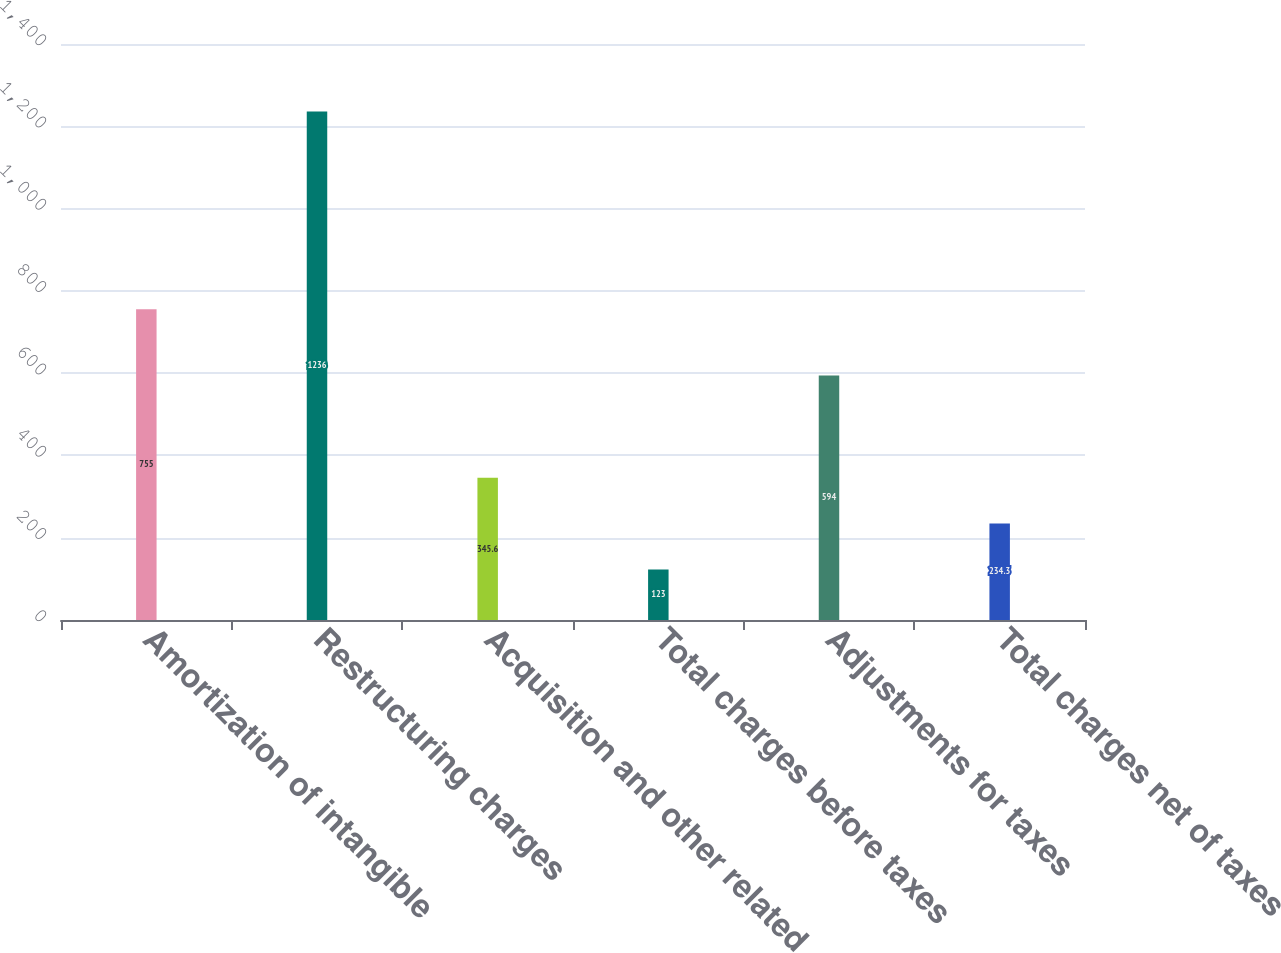Convert chart. <chart><loc_0><loc_0><loc_500><loc_500><bar_chart><fcel>Amortization of intangible<fcel>Restructuring charges<fcel>Acquisition and other related<fcel>Total charges before taxes<fcel>Adjustments for taxes<fcel>Total charges net of taxes<nl><fcel>755<fcel>1236<fcel>345.6<fcel>123<fcel>594<fcel>234.3<nl></chart> 